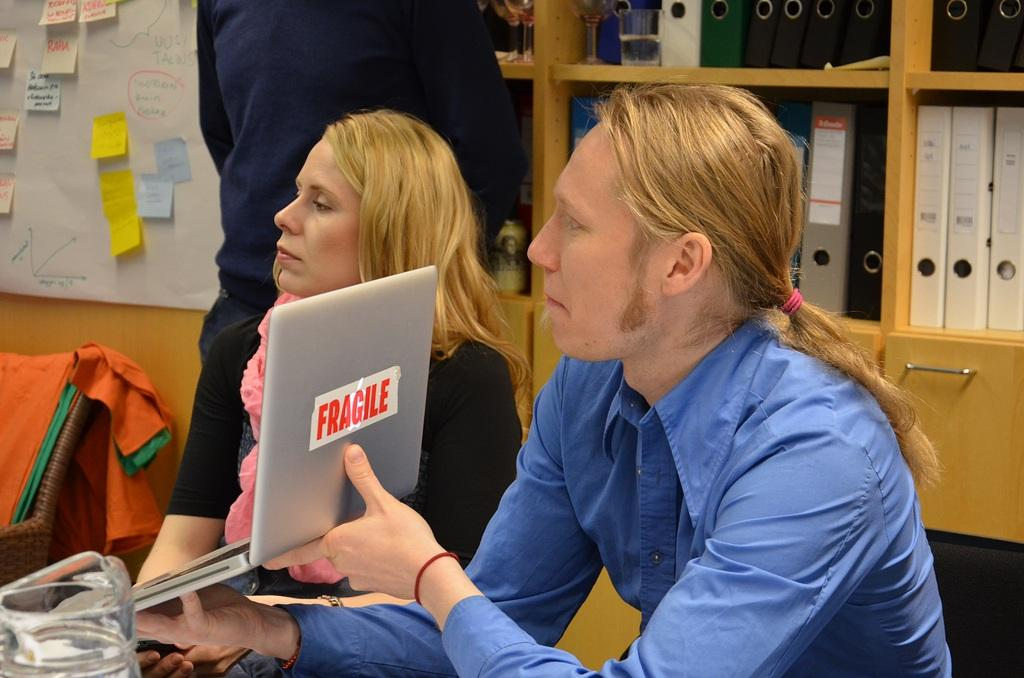How many people are present in the image? There are two persons seated in the image. What is one person doing in the image? One person is holding a laptop. What can be seen in the background of the image? There is a wooden wardrobe in the background. What is stored inside the wooden wardrobe? The wooden wardrobe contains files. What type of fruit is being sliced by the machine in the image? There is no fruit or machine present in the image. How many girls are visible in the image? The image does not show any girls; it features two persons, both of whom appear to be adults. 